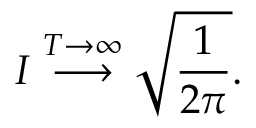Convert formula to latex. <formula><loc_0><loc_0><loc_500><loc_500>I \stackrel { T \rightarrow \infty } { \longrightarrow } \sqrt { \frac { 1 } { 2 \pi } } .</formula> 